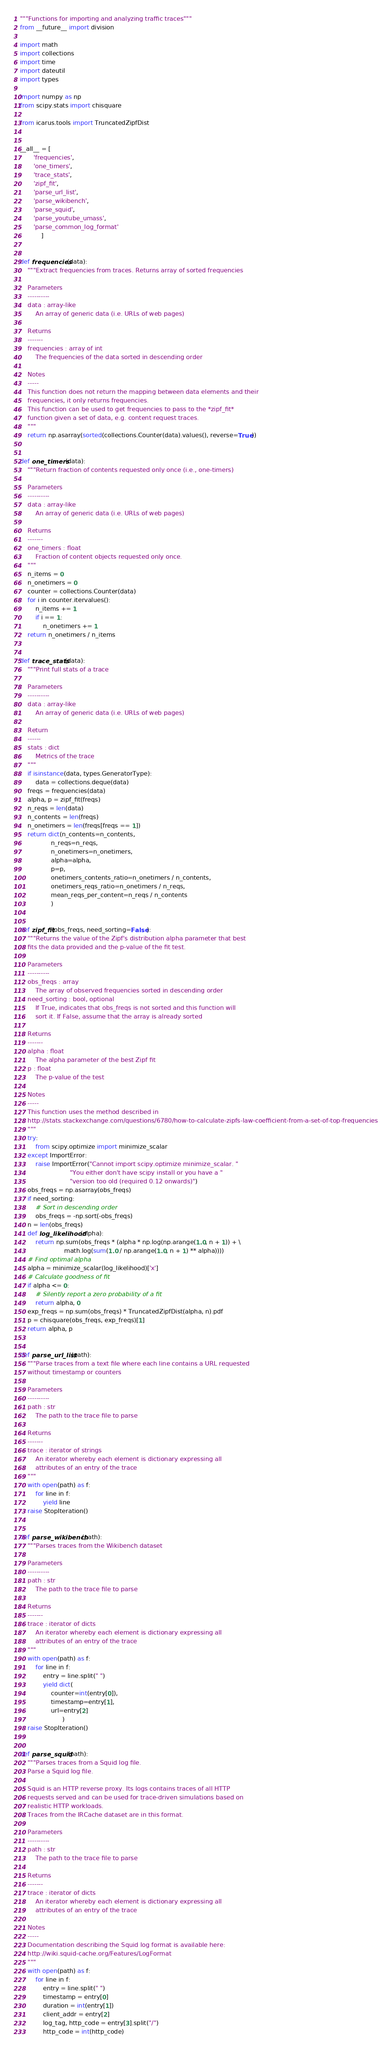<code> <loc_0><loc_0><loc_500><loc_500><_Python_>"""Functions for importing and analyzing traffic traces"""
from __future__ import division

import math
import collections
import time
import dateutil
import types

import numpy as np
from scipy.stats import chisquare

from icarus.tools import TruncatedZipfDist


__all__ = [
       'frequencies',
       'one_timers',
       'trace_stats',
       'zipf_fit',
       'parse_url_list',
       'parse_wikibench',
       'parse_squid',
       'parse_youtube_umass',
       'parse_common_log_format'
           ]


def frequencies(data):
    """Extract frequencies from traces. Returns array of sorted frequencies

    Parameters
    ----------
    data : array-like
        An array of generic data (i.e. URLs of web pages)

    Returns
    -------
    frequencies : array of int
        The frequencies of the data sorted in descending order

    Notes
    -----
    This function does not return the mapping between data elements and their
    frequencies, it only returns frequencies.
    This function can be used to get frequencies to pass to the *zipf_fit*
    function given a set of data, e.g. content request traces.
    """
    return np.asarray(sorted(collections.Counter(data).values(), reverse=True))


def one_timers(data):
    """Return fraction of contents requested only once (i.e., one-timers)

    Parameters
    ----------
    data : array-like
        An array of generic data (i.e. URLs of web pages)

    Returns
    -------
    one_timers : float
        Fraction of content objects requested only once.
    """
    n_items = 0
    n_onetimers = 0
    counter = collections.Counter(data)
    for i in counter.itervalues():
        n_items += 1
        if i == 1:
            n_onetimers += 1
    return n_onetimers / n_items


def trace_stats(data):
    """Print full stats of a trace

    Parameters
    ----------
    data : array-like
        An array of generic data (i.e. URLs of web pages)

    Return
    ------
    stats : dict
        Metrics of the trace
    """
    if isinstance(data, types.GeneratorType):
        data = collections.deque(data)
    freqs = frequencies(data)
    alpha, p = zipf_fit(freqs)
    n_reqs = len(data)
    n_contents = len(freqs)
    n_onetimers = len(freqs[freqs == 1])
    return dict(n_contents=n_contents,
                n_reqs=n_reqs,
                n_onetimers=n_onetimers,
                alpha=alpha,
                p=p,
                onetimers_contents_ratio=n_onetimers / n_contents,
                onetimers_reqs_ratio=n_onetimers / n_reqs,
                mean_reqs_per_content=n_reqs / n_contents
                )


def zipf_fit(obs_freqs, need_sorting=False):
    """Returns the value of the Zipf's distribution alpha parameter that best
    fits the data provided and the p-value of the fit test.

    Parameters
    ----------
    obs_freqs : array
        The array of observed frequencies sorted in descending order
    need_sorting : bool, optional
        If True, indicates that obs_freqs is not sorted and this function will
        sort it. If False, assume that the array is already sorted

    Returns
    -------
    alpha : float
        The alpha parameter of the best Zipf fit
    p : float
        The p-value of the test

    Notes
    -----
    This function uses the method described in
    http://stats.stackexchange.com/questions/6780/how-to-calculate-zipfs-law-coefficient-from-a-set-of-top-frequencies
    """
    try:
        from scipy.optimize import minimize_scalar
    except ImportError:
        raise ImportError("Cannot import scipy.optimize minimize_scalar. "
                          "You either don't have scipy install or you have a "
                          "version too old (required 0.12 onwards)")
    obs_freqs = np.asarray(obs_freqs)
    if need_sorting:
        # Sort in descending order
        obs_freqs = -np.sort(-obs_freqs)
    n = len(obs_freqs)
    def log_likelihood(alpha):
        return np.sum(obs_freqs * (alpha * np.log(np.arange(1.0, n + 1)) + \
                       math.log(sum(1.0 / np.arange(1.0, n + 1) ** alpha))))
    # Find optimal alpha
    alpha = minimize_scalar(log_likelihood)['x']
    # Calculate goodness of fit
    if alpha <= 0:
        # Silently report a zero probability of a fit
        return alpha, 0
    exp_freqs = np.sum(obs_freqs) * TruncatedZipfDist(alpha, n).pdf
    p = chisquare(obs_freqs, exp_freqs)[1]
    return alpha, p


def parse_url_list(path):
    """Parse traces from a text file where each line contains a URL requested
    without timestamp or counters

    Parameters
    ----------
    path : str
        The path to the trace file to parse

    Returns
    -------
    trace : iterator of strings
        An iterator whereby each element is dictionary expressing all
        attributes of an entry of the trace
    """
    with open(path) as f:
        for line in f:
            yield line
    raise StopIteration()


def parse_wikibench(path):
    """Parses traces from the Wikibench dataset

    Parameters
    ----------
    path : str
        The path to the trace file to parse

    Returns
    -------
    trace : iterator of dicts
        An iterator whereby each element is dictionary expressing all
        attributes of an entry of the trace
    """
    with open(path) as f:
        for line in f:
            entry = line.split(" ")
            yield dict(
                counter=int(entry[0]),
                timestamp=entry[1],
                url=entry[2]
                      )
    raise StopIteration()


def parse_squid(path):
    """Parses traces from a Squid log file.
    Parse a Squid log file.

    Squid is an HTTP reverse proxy. Its logs contains traces of all HTTP
    requests served and can be used for trace-driven simulations based on
    realistic HTTP workloads.
    Traces from the IRCache dataset are in this format.

    Parameters
    ----------
    path : str
        The path to the trace file to parse

    Returns
    -------
    trace : iterator of dicts
        An iterator whereby each element is dictionary expressing all
        attributes of an entry of the trace

    Notes
    -----
    Documentation describing the Squid log format is available here:
    http://wiki.squid-cache.org/Features/LogFormat
    """
    with open(path) as f:
        for line in f:
            entry = line.split(" ")
            timestamp = entry[0]
            duration = int(entry[1])
            client_addr = entry[2]
            log_tag, http_code = entry[3].split("/")
            http_code = int(http_code)</code> 